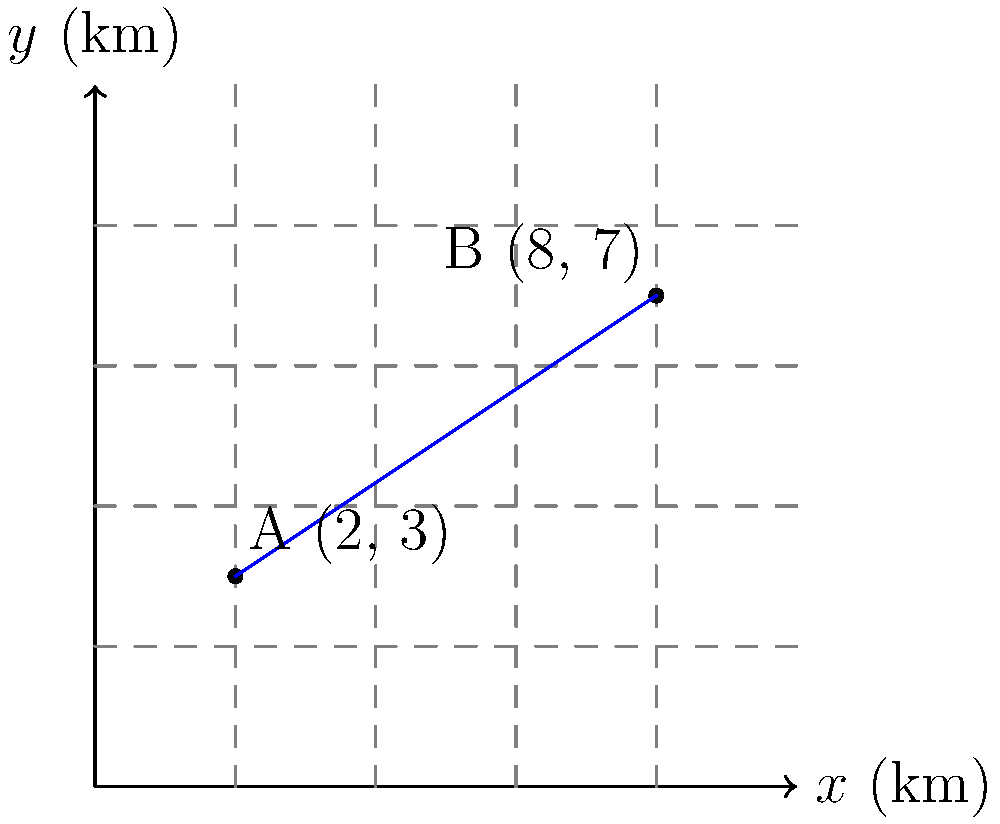As a military strategist during the ongoing conflict, you need to calculate the direct distance between two strategic positions. Position A is located at coordinates (2 km, 3 km), and Position B is at (8 km, 7 km) on your tactical map. Using the distance formula, determine the straight-line distance between these two positions. Round your answer to the nearest tenth of a kilometer. To solve this problem, we'll use the distance formula derived from the Pythagorean theorem:

$$d = \sqrt{(x_2 - x_1)^2 + (y_2 - y_1)^2}$$

Where:
$(x_1, y_1)$ are the coordinates of Position A (2, 3)
$(x_2, y_2)$ are the coordinates of Position B (8, 7)

Let's substitute these values into the formula:

$$d = \sqrt{(8 - 2)^2 + (7 - 3)^2}$$

Now, let's solve step by step:

1) Simplify the expressions inside the parentheses:
   $$d = \sqrt{6^2 + 4^2}$$

2) Calculate the squares:
   $$d = \sqrt{36 + 16}$$

3) Add the numbers under the square root:
   $$d = \sqrt{52}$$

4) Calculate the square root and round to the nearest tenth:
   $$d \approx 7.2$$

Therefore, the straight-line distance between Position A and Position B is approximately 7.2 km.
Answer: 7.2 km 